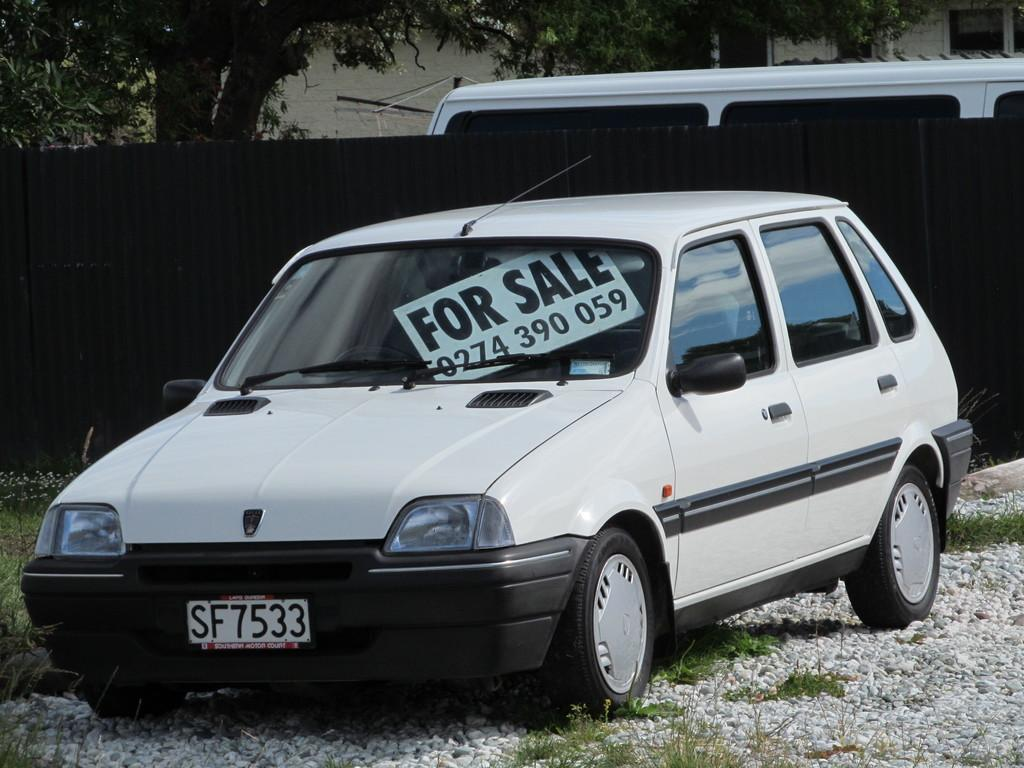<image>
Share a concise interpretation of the image provided. An old car stands with a for sale sign with a phone number in its window. 